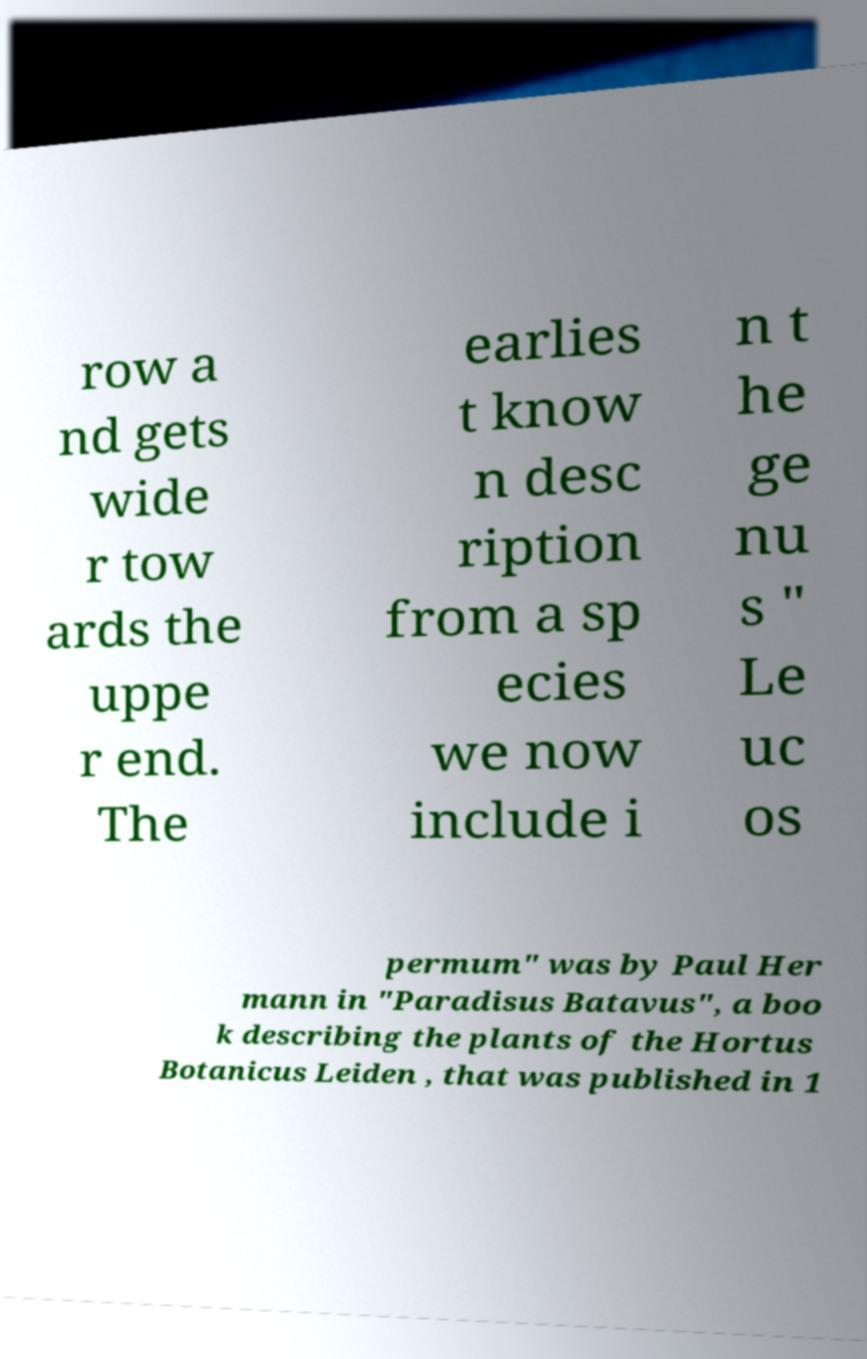Please identify and transcribe the text found in this image. row a nd gets wide r tow ards the uppe r end. The earlies t know n desc ription from a sp ecies we now include i n t he ge nu s " Le uc os permum" was by Paul Her mann in "Paradisus Batavus", a boo k describing the plants of the Hortus Botanicus Leiden , that was published in 1 